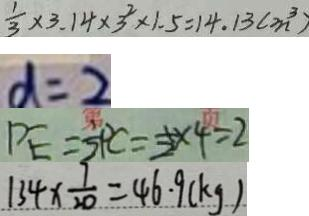<formula> <loc_0><loc_0><loc_500><loc_500>\frac { 1 } { 3 } \times 3 . 1 4 \times 3 ^ { 2 } \times 1 . 5 = 1 4 . 1 3 ( m ^ { 3 } ) 
 d = 2 
 P E = \frac { 1 } { 2 } P C = \frac { 1 } { 2 } \times 4 = 2 
 1 3 4 \times \frac { 7 } { 2 0 } = 4 6 . 9 ( k g )</formula> 